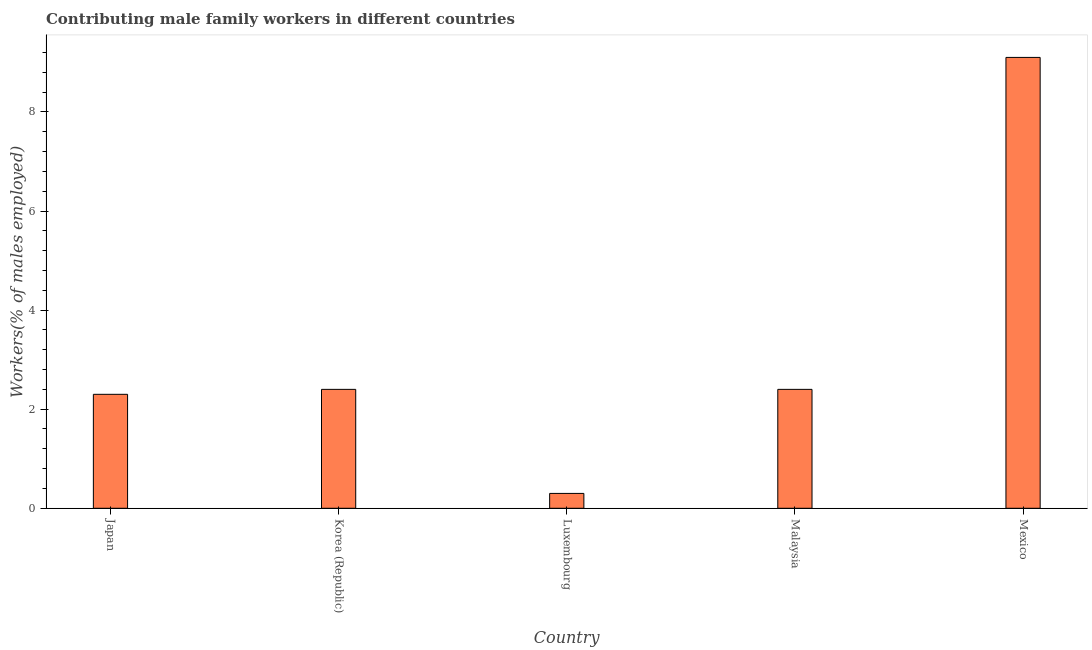Does the graph contain any zero values?
Your answer should be very brief. No. What is the title of the graph?
Make the answer very short. Contributing male family workers in different countries. What is the label or title of the Y-axis?
Provide a succinct answer. Workers(% of males employed). What is the contributing male family workers in Korea (Republic)?
Give a very brief answer. 2.4. Across all countries, what is the maximum contributing male family workers?
Ensure brevity in your answer.  9.1. Across all countries, what is the minimum contributing male family workers?
Provide a succinct answer. 0.3. In which country was the contributing male family workers minimum?
Your answer should be very brief. Luxembourg. What is the sum of the contributing male family workers?
Provide a short and direct response. 16.5. What is the average contributing male family workers per country?
Provide a short and direct response. 3.3. What is the median contributing male family workers?
Your answer should be compact. 2.4. What is the ratio of the contributing male family workers in Korea (Republic) to that in Luxembourg?
Keep it short and to the point. 8. Is the contributing male family workers in Luxembourg less than that in Mexico?
Give a very brief answer. Yes. What is the difference between the highest and the second highest contributing male family workers?
Offer a terse response. 6.7. Are the values on the major ticks of Y-axis written in scientific E-notation?
Provide a short and direct response. No. What is the Workers(% of males employed) of Japan?
Offer a terse response. 2.3. What is the Workers(% of males employed) in Korea (Republic)?
Offer a very short reply. 2.4. What is the Workers(% of males employed) in Luxembourg?
Make the answer very short. 0.3. What is the Workers(% of males employed) in Malaysia?
Keep it short and to the point. 2.4. What is the Workers(% of males employed) of Mexico?
Your answer should be very brief. 9.1. What is the difference between the Workers(% of males employed) in Japan and Luxembourg?
Give a very brief answer. 2. What is the difference between the Workers(% of males employed) in Japan and Malaysia?
Provide a short and direct response. -0.1. What is the difference between the Workers(% of males employed) in Japan and Mexico?
Make the answer very short. -6.8. What is the difference between the Workers(% of males employed) in Korea (Republic) and Luxembourg?
Your answer should be very brief. 2.1. What is the difference between the Workers(% of males employed) in Korea (Republic) and Malaysia?
Provide a succinct answer. 0. What is the difference between the Workers(% of males employed) in Korea (Republic) and Mexico?
Provide a short and direct response. -6.7. What is the difference between the Workers(% of males employed) in Luxembourg and Mexico?
Keep it short and to the point. -8.8. What is the difference between the Workers(% of males employed) in Malaysia and Mexico?
Your response must be concise. -6.7. What is the ratio of the Workers(% of males employed) in Japan to that in Korea (Republic)?
Your answer should be compact. 0.96. What is the ratio of the Workers(% of males employed) in Japan to that in Luxembourg?
Offer a very short reply. 7.67. What is the ratio of the Workers(% of males employed) in Japan to that in Malaysia?
Your answer should be very brief. 0.96. What is the ratio of the Workers(% of males employed) in Japan to that in Mexico?
Keep it short and to the point. 0.25. What is the ratio of the Workers(% of males employed) in Korea (Republic) to that in Luxembourg?
Provide a succinct answer. 8. What is the ratio of the Workers(% of males employed) in Korea (Republic) to that in Malaysia?
Offer a very short reply. 1. What is the ratio of the Workers(% of males employed) in Korea (Republic) to that in Mexico?
Provide a short and direct response. 0.26. What is the ratio of the Workers(% of males employed) in Luxembourg to that in Mexico?
Provide a short and direct response. 0.03. What is the ratio of the Workers(% of males employed) in Malaysia to that in Mexico?
Offer a very short reply. 0.26. 